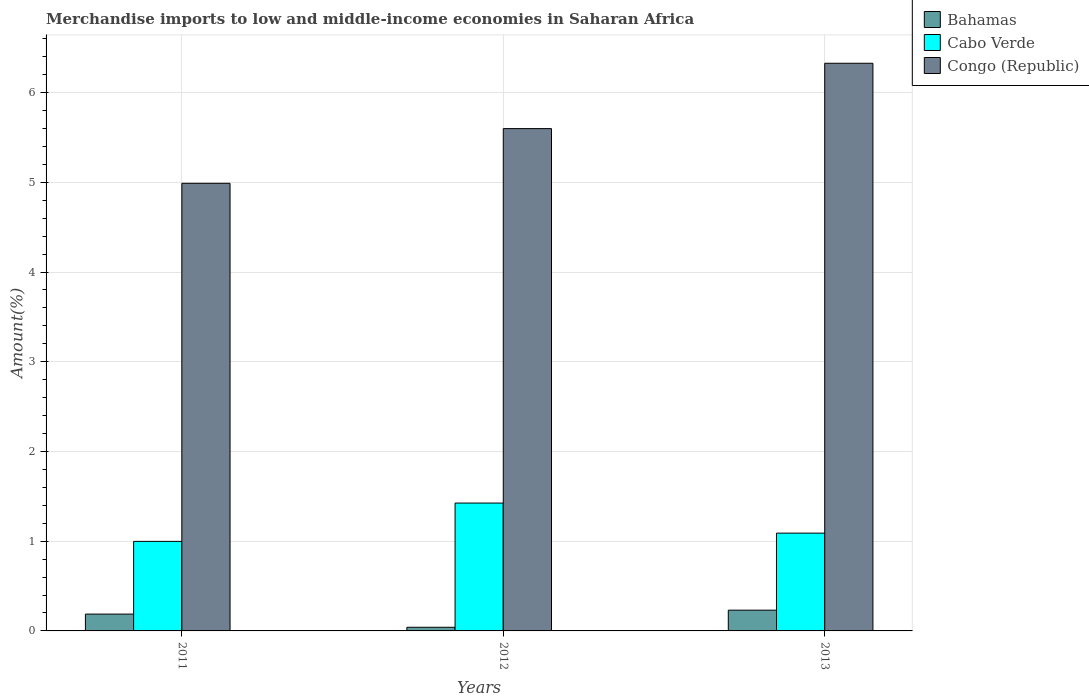How many different coloured bars are there?
Your answer should be very brief. 3. How many groups of bars are there?
Provide a succinct answer. 3. Are the number of bars on each tick of the X-axis equal?
Offer a terse response. Yes. How many bars are there on the 1st tick from the left?
Keep it short and to the point. 3. How many bars are there on the 2nd tick from the right?
Your response must be concise. 3. What is the label of the 3rd group of bars from the left?
Your answer should be very brief. 2013. In how many cases, is the number of bars for a given year not equal to the number of legend labels?
Provide a succinct answer. 0. What is the percentage of amount earned from merchandise imports in Bahamas in 2012?
Give a very brief answer. 0.04. Across all years, what is the maximum percentage of amount earned from merchandise imports in Congo (Republic)?
Make the answer very short. 6.33. Across all years, what is the minimum percentage of amount earned from merchandise imports in Congo (Republic)?
Offer a terse response. 4.99. In which year was the percentage of amount earned from merchandise imports in Cabo Verde maximum?
Keep it short and to the point. 2012. In which year was the percentage of amount earned from merchandise imports in Bahamas minimum?
Your answer should be very brief. 2012. What is the total percentage of amount earned from merchandise imports in Bahamas in the graph?
Offer a terse response. 0.46. What is the difference between the percentage of amount earned from merchandise imports in Congo (Republic) in 2011 and that in 2012?
Offer a terse response. -0.61. What is the difference between the percentage of amount earned from merchandise imports in Bahamas in 2011 and the percentage of amount earned from merchandise imports in Cabo Verde in 2013?
Keep it short and to the point. -0.9. What is the average percentage of amount earned from merchandise imports in Congo (Republic) per year?
Your answer should be compact. 5.64. In the year 2013, what is the difference between the percentage of amount earned from merchandise imports in Bahamas and percentage of amount earned from merchandise imports in Cabo Verde?
Make the answer very short. -0.86. What is the ratio of the percentage of amount earned from merchandise imports in Congo (Republic) in 2011 to that in 2012?
Offer a terse response. 0.89. Is the percentage of amount earned from merchandise imports in Bahamas in 2011 less than that in 2013?
Provide a short and direct response. Yes. Is the difference between the percentage of amount earned from merchandise imports in Bahamas in 2012 and 2013 greater than the difference between the percentage of amount earned from merchandise imports in Cabo Verde in 2012 and 2013?
Your answer should be very brief. No. What is the difference between the highest and the second highest percentage of amount earned from merchandise imports in Bahamas?
Your answer should be compact. 0.04. What is the difference between the highest and the lowest percentage of amount earned from merchandise imports in Congo (Republic)?
Provide a succinct answer. 1.34. What does the 1st bar from the left in 2013 represents?
Make the answer very short. Bahamas. What does the 3rd bar from the right in 2013 represents?
Provide a short and direct response. Bahamas. Is it the case that in every year, the sum of the percentage of amount earned from merchandise imports in Cabo Verde and percentage of amount earned from merchandise imports in Congo (Republic) is greater than the percentage of amount earned from merchandise imports in Bahamas?
Make the answer very short. Yes. Does the graph contain grids?
Provide a succinct answer. Yes. How many legend labels are there?
Offer a very short reply. 3. What is the title of the graph?
Ensure brevity in your answer.  Merchandise imports to low and middle-income economies in Saharan Africa. What is the label or title of the X-axis?
Provide a short and direct response. Years. What is the label or title of the Y-axis?
Offer a very short reply. Amount(%). What is the Amount(%) in Bahamas in 2011?
Your answer should be very brief. 0.19. What is the Amount(%) in Cabo Verde in 2011?
Offer a very short reply. 1. What is the Amount(%) of Congo (Republic) in 2011?
Make the answer very short. 4.99. What is the Amount(%) in Bahamas in 2012?
Your response must be concise. 0.04. What is the Amount(%) of Cabo Verde in 2012?
Your answer should be very brief. 1.43. What is the Amount(%) of Congo (Republic) in 2012?
Ensure brevity in your answer.  5.6. What is the Amount(%) of Bahamas in 2013?
Give a very brief answer. 0.23. What is the Amount(%) in Cabo Verde in 2013?
Your response must be concise. 1.09. What is the Amount(%) of Congo (Republic) in 2013?
Your answer should be very brief. 6.33. Across all years, what is the maximum Amount(%) of Bahamas?
Ensure brevity in your answer.  0.23. Across all years, what is the maximum Amount(%) of Cabo Verde?
Keep it short and to the point. 1.43. Across all years, what is the maximum Amount(%) of Congo (Republic)?
Keep it short and to the point. 6.33. Across all years, what is the minimum Amount(%) of Bahamas?
Your response must be concise. 0.04. Across all years, what is the minimum Amount(%) in Cabo Verde?
Provide a short and direct response. 1. Across all years, what is the minimum Amount(%) of Congo (Republic)?
Offer a terse response. 4.99. What is the total Amount(%) in Bahamas in the graph?
Keep it short and to the point. 0.46. What is the total Amount(%) of Cabo Verde in the graph?
Offer a very short reply. 3.51. What is the total Amount(%) of Congo (Republic) in the graph?
Your answer should be very brief. 16.91. What is the difference between the Amount(%) in Bahamas in 2011 and that in 2012?
Your response must be concise. 0.15. What is the difference between the Amount(%) in Cabo Verde in 2011 and that in 2012?
Provide a succinct answer. -0.43. What is the difference between the Amount(%) of Congo (Republic) in 2011 and that in 2012?
Your answer should be very brief. -0.61. What is the difference between the Amount(%) of Bahamas in 2011 and that in 2013?
Make the answer very short. -0.04. What is the difference between the Amount(%) of Cabo Verde in 2011 and that in 2013?
Keep it short and to the point. -0.09. What is the difference between the Amount(%) of Congo (Republic) in 2011 and that in 2013?
Your answer should be very brief. -1.34. What is the difference between the Amount(%) of Bahamas in 2012 and that in 2013?
Provide a short and direct response. -0.19. What is the difference between the Amount(%) in Cabo Verde in 2012 and that in 2013?
Offer a very short reply. 0.34. What is the difference between the Amount(%) in Congo (Republic) in 2012 and that in 2013?
Provide a succinct answer. -0.73. What is the difference between the Amount(%) in Bahamas in 2011 and the Amount(%) in Cabo Verde in 2012?
Keep it short and to the point. -1.24. What is the difference between the Amount(%) of Bahamas in 2011 and the Amount(%) of Congo (Republic) in 2012?
Provide a short and direct response. -5.41. What is the difference between the Amount(%) of Cabo Verde in 2011 and the Amount(%) of Congo (Republic) in 2012?
Give a very brief answer. -4.6. What is the difference between the Amount(%) of Bahamas in 2011 and the Amount(%) of Cabo Verde in 2013?
Give a very brief answer. -0.9. What is the difference between the Amount(%) in Bahamas in 2011 and the Amount(%) in Congo (Republic) in 2013?
Your answer should be very brief. -6.14. What is the difference between the Amount(%) in Cabo Verde in 2011 and the Amount(%) in Congo (Republic) in 2013?
Your response must be concise. -5.33. What is the difference between the Amount(%) of Bahamas in 2012 and the Amount(%) of Cabo Verde in 2013?
Keep it short and to the point. -1.05. What is the difference between the Amount(%) in Bahamas in 2012 and the Amount(%) in Congo (Republic) in 2013?
Your answer should be very brief. -6.29. What is the difference between the Amount(%) in Cabo Verde in 2012 and the Amount(%) in Congo (Republic) in 2013?
Keep it short and to the point. -4.9. What is the average Amount(%) of Bahamas per year?
Provide a short and direct response. 0.15. What is the average Amount(%) in Cabo Verde per year?
Your answer should be very brief. 1.17. What is the average Amount(%) in Congo (Republic) per year?
Offer a terse response. 5.64. In the year 2011, what is the difference between the Amount(%) in Bahamas and Amount(%) in Cabo Verde?
Make the answer very short. -0.81. In the year 2011, what is the difference between the Amount(%) of Bahamas and Amount(%) of Congo (Republic)?
Keep it short and to the point. -4.8. In the year 2011, what is the difference between the Amount(%) in Cabo Verde and Amount(%) in Congo (Republic)?
Provide a succinct answer. -3.99. In the year 2012, what is the difference between the Amount(%) of Bahamas and Amount(%) of Cabo Verde?
Ensure brevity in your answer.  -1.38. In the year 2012, what is the difference between the Amount(%) of Bahamas and Amount(%) of Congo (Republic)?
Ensure brevity in your answer.  -5.56. In the year 2012, what is the difference between the Amount(%) in Cabo Verde and Amount(%) in Congo (Republic)?
Make the answer very short. -4.17. In the year 2013, what is the difference between the Amount(%) in Bahamas and Amount(%) in Cabo Verde?
Give a very brief answer. -0.86. In the year 2013, what is the difference between the Amount(%) in Bahamas and Amount(%) in Congo (Republic)?
Offer a very short reply. -6.1. In the year 2013, what is the difference between the Amount(%) of Cabo Verde and Amount(%) of Congo (Republic)?
Offer a terse response. -5.24. What is the ratio of the Amount(%) in Bahamas in 2011 to that in 2012?
Your answer should be compact. 4.61. What is the ratio of the Amount(%) in Cabo Verde in 2011 to that in 2012?
Offer a terse response. 0.7. What is the ratio of the Amount(%) of Congo (Republic) in 2011 to that in 2012?
Ensure brevity in your answer.  0.89. What is the ratio of the Amount(%) of Bahamas in 2011 to that in 2013?
Your answer should be compact. 0.81. What is the ratio of the Amount(%) in Cabo Verde in 2011 to that in 2013?
Offer a very short reply. 0.92. What is the ratio of the Amount(%) of Congo (Republic) in 2011 to that in 2013?
Ensure brevity in your answer.  0.79. What is the ratio of the Amount(%) of Bahamas in 2012 to that in 2013?
Provide a short and direct response. 0.18. What is the ratio of the Amount(%) of Cabo Verde in 2012 to that in 2013?
Offer a very short reply. 1.31. What is the ratio of the Amount(%) in Congo (Republic) in 2012 to that in 2013?
Offer a terse response. 0.88. What is the difference between the highest and the second highest Amount(%) in Bahamas?
Ensure brevity in your answer.  0.04. What is the difference between the highest and the second highest Amount(%) of Cabo Verde?
Your answer should be compact. 0.34. What is the difference between the highest and the second highest Amount(%) in Congo (Republic)?
Provide a succinct answer. 0.73. What is the difference between the highest and the lowest Amount(%) in Bahamas?
Ensure brevity in your answer.  0.19. What is the difference between the highest and the lowest Amount(%) of Cabo Verde?
Your response must be concise. 0.43. What is the difference between the highest and the lowest Amount(%) of Congo (Republic)?
Make the answer very short. 1.34. 